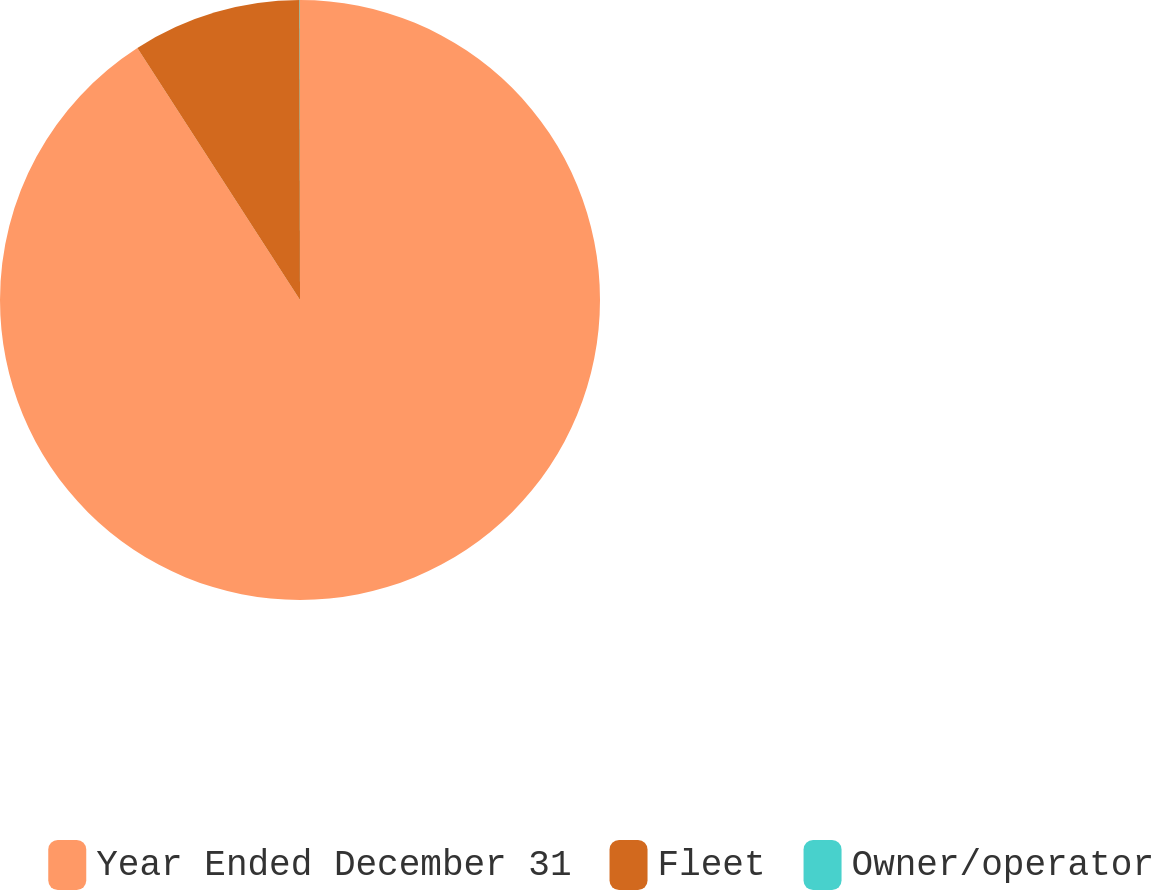Convert chart. <chart><loc_0><loc_0><loc_500><loc_500><pie_chart><fcel>Year Ended December 31<fcel>Fleet<fcel>Owner/operator<nl><fcel>90.88%<fcel>9.1%<fcel>0.02%<nl></chart> 